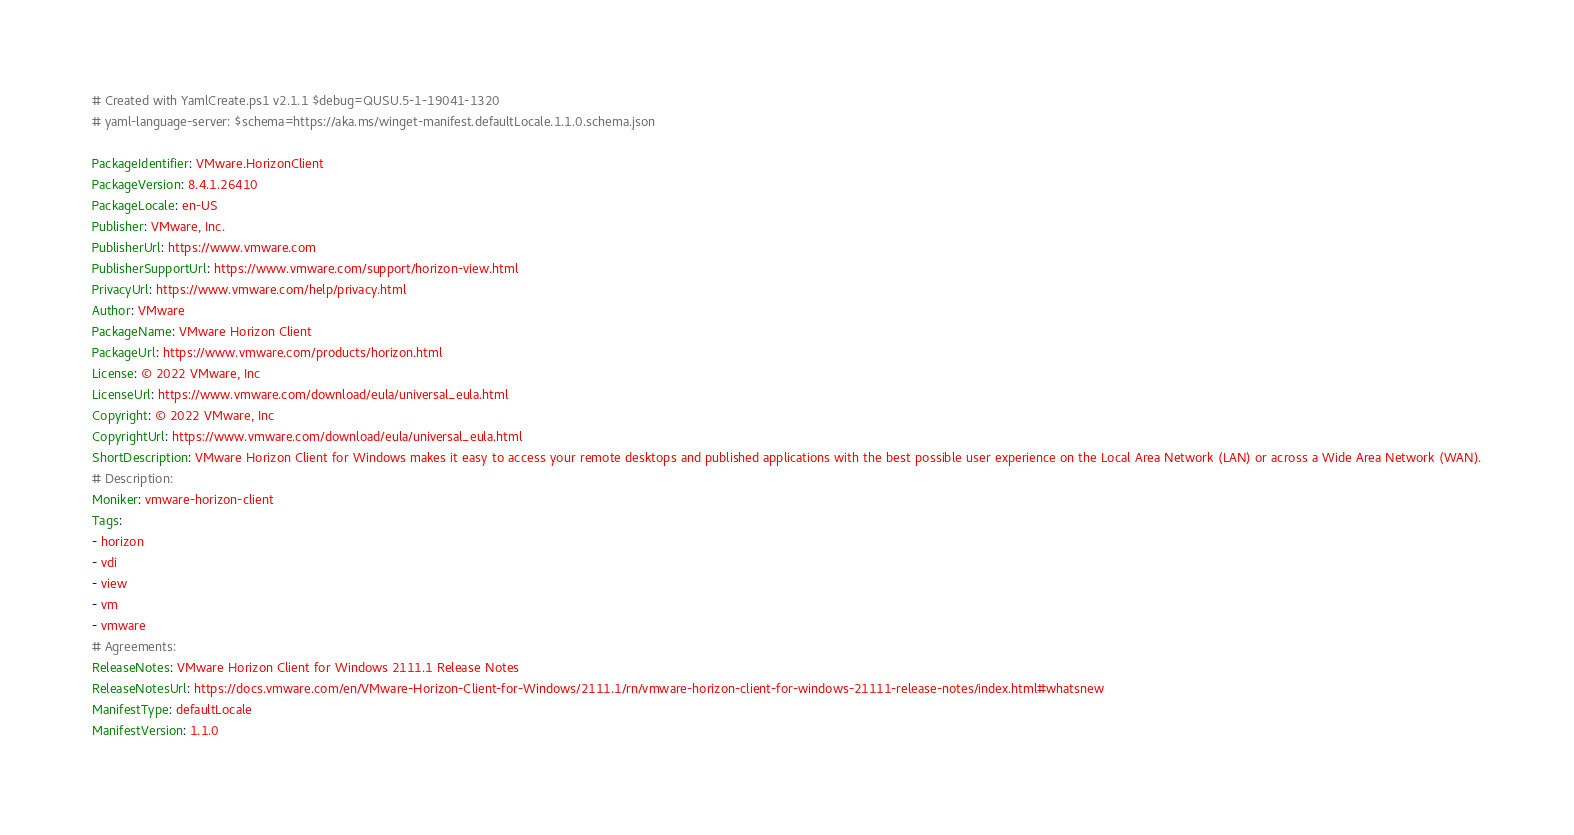<code> <loc_0><loc_0><loc_500><loc_500><_YAML_># Created with YamlCreate.ps1 v2.1.1 $debug=QUSU.5-1-19041-1320
# yaml-language-server: $schema=https://aka.ms/winget-manifest.defaultLocale.1.1.0.schema.json

PackageIdentifier: VMware.HorizonClient
PackageVersion: 8.4.1.26410
PackageLocale: en-US
Publisher: VMware, Inc.
PublisherUrl: https://www.vmware.com
PublisherSupportUrl: https://www.vmware.com/support/horizon-view.html
PrivacyUrl: https://www.vmware.com/help/privacy.html
Author: VMware
PackageName: VMware Horizon Client
PackageUrl: https://www.vmware.com/products/horizon.html
License: © 2022 VMware, Inc
LicenseUrl: https://www.vmware.com/download/eula/universal_eula.html
Copyright: © 2022 VMware, Inc
CopyrightUrl: https://www.vmware.com/download/eula/universal_eula.html
ShortDescription: VMware Horizon Client for Windows makes it easy to access your remote desktops and published applications with the best possible user experience on the Local Area Network (LAN) or across a Wide Area Network (WAN).
# Description: 
Moniker: vmware-horizon-client
Tags:
- horizon
- vdi
- view
- vm
- vmware
# Agreements: 
ReleaseNotes: VMware Horizon Client for Windows 2111.1 Release Notes
ReleaseNotesUrl: https://docs.vmware.com/en/VMware-Horizon-Client-for-Windows/2111.1/rn/vmware-horizon-client-for-windows-21111-release-notes/index.html#whatsnew
ManifestType: defaultLocale
ManifestVersion: 1.1.0
</code> 